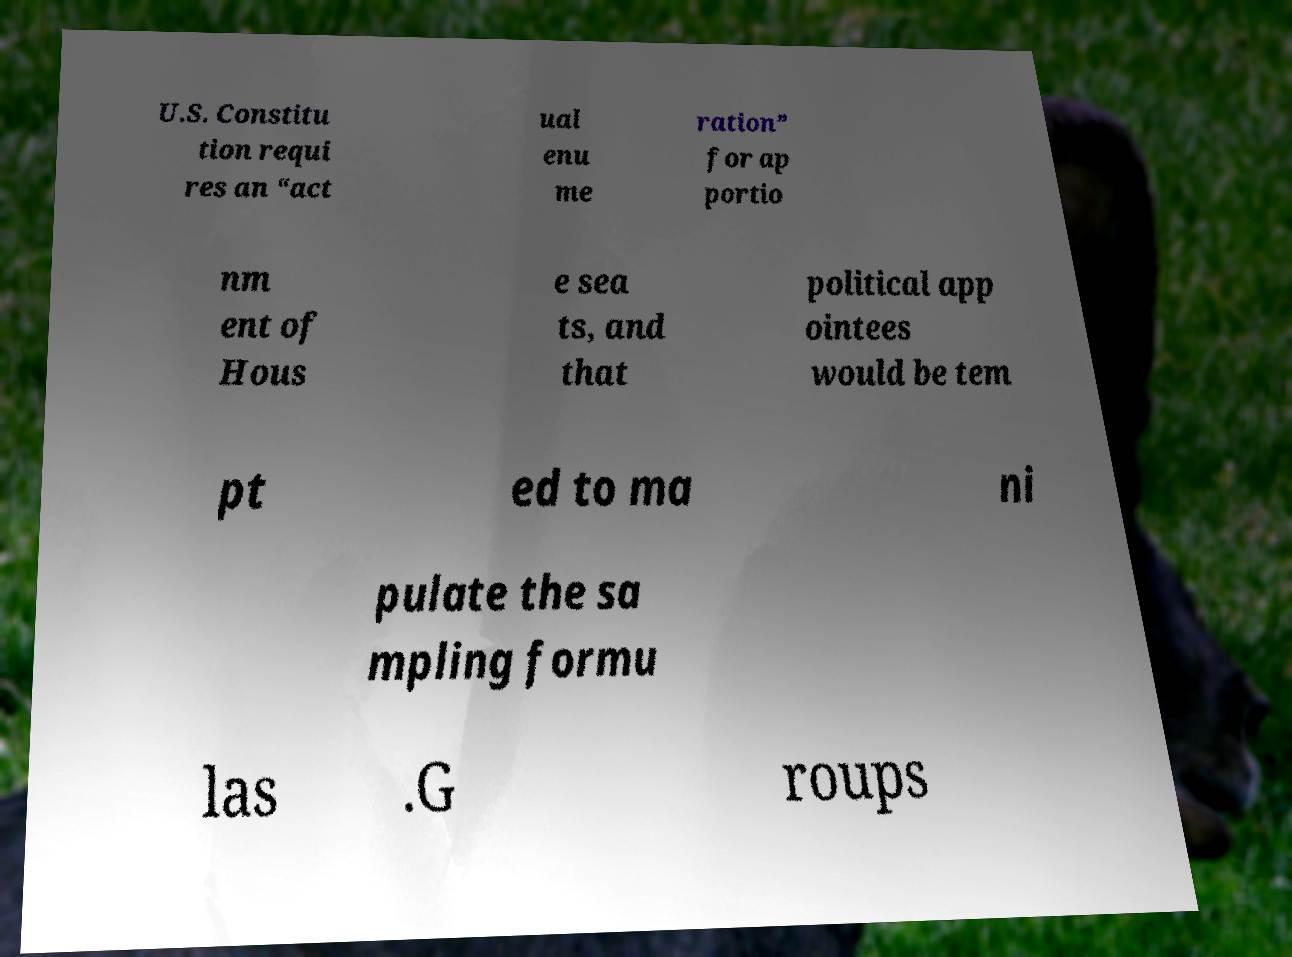Could you extract and type out the text from this image? U.S. Constitu tion requi res an “act ual enu me ration” for ap portio nm ent of Hous e sea ts, and that political app ointees would be tem pt ed to ma ni pulate the sa mpling formu las .G roups 